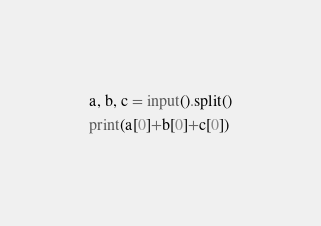Convert code to text. <code><loc_0><loc_0><loc_500><loc_500><_Python_>a, b, c = input().split()
print(a[0]+b[0]+c[0])
</code> 